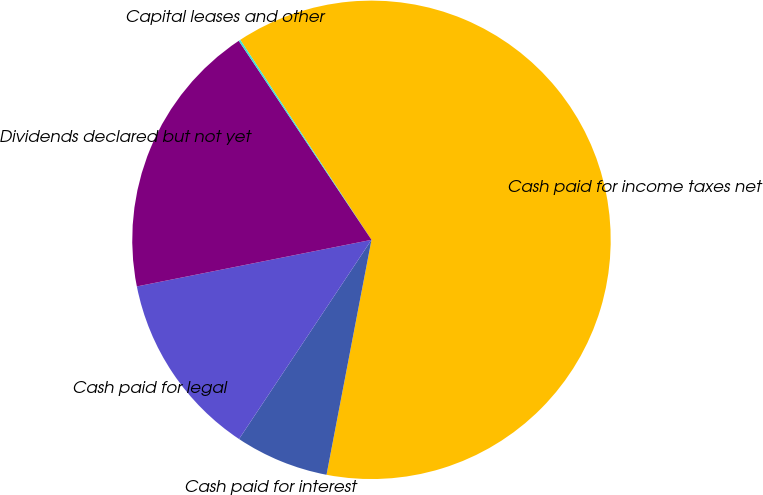Convert chart. <chart><loc_0><loc_0><loc_500><loc_500><pie_chart><fcel>Cash paid for income taxes net<fcel>Cash paid for interest<fcel>Cash paid for legal<fcel>Dividends declared but not yet<fcel>Capital leases and other<nl><fcel>62.25%<fcel>6.33%<fcel>12.54%<fcel>18.76%<fcel>0.12%<nl></chart> 